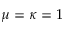Convert formula to latex. <formula><loc_0><loc_0><loc_500><loc_500>\mu = \kappa = 1</formula> 